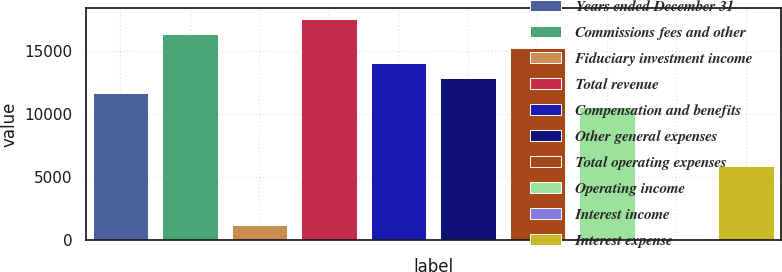Convert chart. <chart><loc_0><loc_0><loc_500><loc_500><bar_chart><fcel>Years ended December 31<fcel>Commissions fees and other<fcel>Fiduciary investment income<fcel>Total revenue<fcel>Compensation and benefits<fcel>Other general expenses<fcel>Total operating expenses<fcel>Operating income<fcel>Interest income<fcel>Interest expense<nl><fcel>11682<fcel>16349.2<fcel>1180.8<fcel>17516<fcel>14015.6<fcel>12848.8<fcel>15182.4<fcel>10515.2<fcel>14<fcel>5848<nl></chart> 